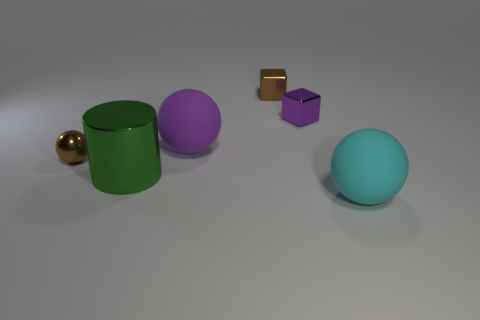How many tiny metal blocks have the same color as the metallic sphere?
Give a very brief answer. 1. How many things are tiny shiny things in front of the small purple block or tiny shiny things?
Offer a terse response. 3. How many other objects are the same shape as the purple rubber object?
Ensure brevity in your answer.  2. There is a large rubber thing behind the big metal cylinder; is it the same shape as the big cyan rubber object?
Give a very brief answer. Yes. There is a big cyan matte thing; are there any purple spheres to the right of it?
Ensure brevity in your answer.  No. What number of tiny objects are either brown rubber cubes or metal balls?
Keep it short and to the point. 1. Does the small purple object have the same material as the green cylinder?
Make the answer very short. Yes. The metal block that is the same color as the small metallic ball is what size?
Your response must be concise. Small. Is there a big object that has the same color as the large cylinder?
Make the answer very short. No. The sphere that is the same material as the big green cylinder is what size?
Provide a short and direct response. Small. 